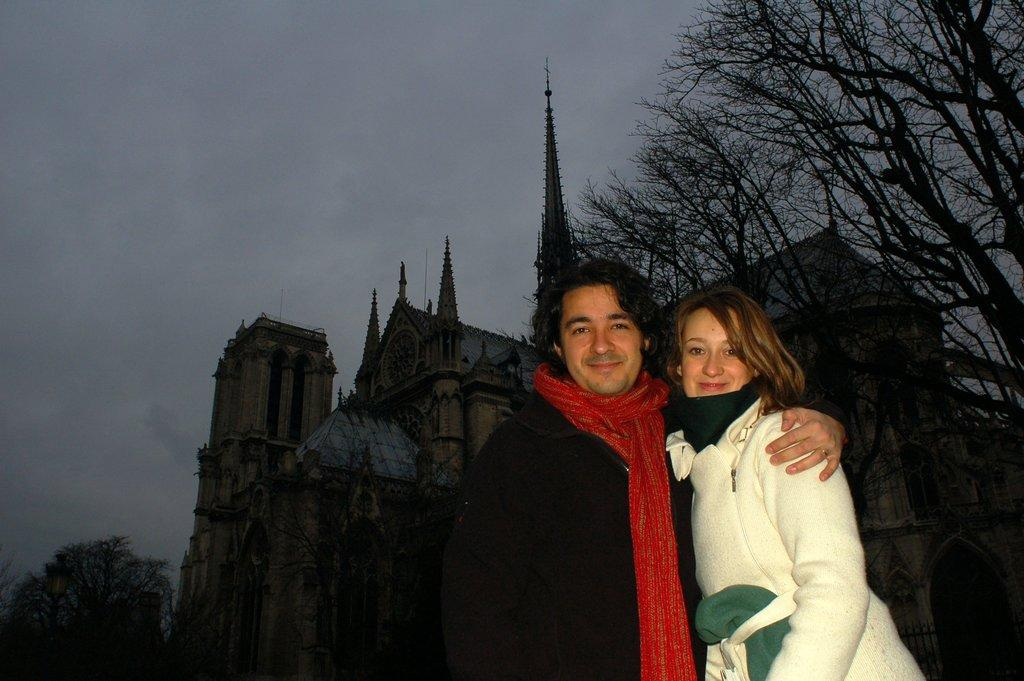What are the people in the image doing? The people in the image are standing and smiling. What can be seen in the background of the image? There is a building and trees in the background of the image. What is the condition of the sky in the image? The sky is cloudy in the image. What type of suit is the brother wearing in the image? There is no brother present in the image, and no one is wearing a suit. 